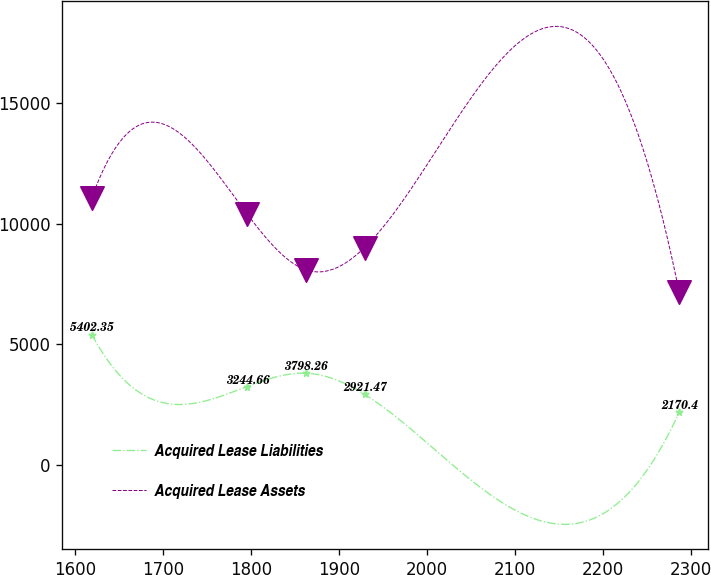Convert chart to OTSL. <chart><loc_0><loc_0><loc_500><loc_500><line_chart><ecel><fcel>Acquired Lease Liabilities<fcel>Acquired Lease Assets<nl><fcel>1619.07<fcel>5402.35<fcel>11071.9<nl><fcel>1795.67<fcel>3244.66<fcel>10397.3<nl><fcel>1862.43<fcel>3798.26<fcel>8081.63<nl><fcel>1929.19<fcel>2921.47<fcel>9006.94<nl><fcel>2286.67<fcel>2170.4<fcel>7180.14<nl></chart> 